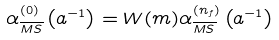<formula> <loc_0><loc_0><loc_500><loc_500>\alpha _ { \overline { M S } } ^ { ( 0 ) } \left ( a ^ { - 1 } \right ) = W ( m ) \alpha _ { \overline { M S } } ^ { ( n _ { f } ) } \left ( a ^ { - 1 } \right )</formula> 